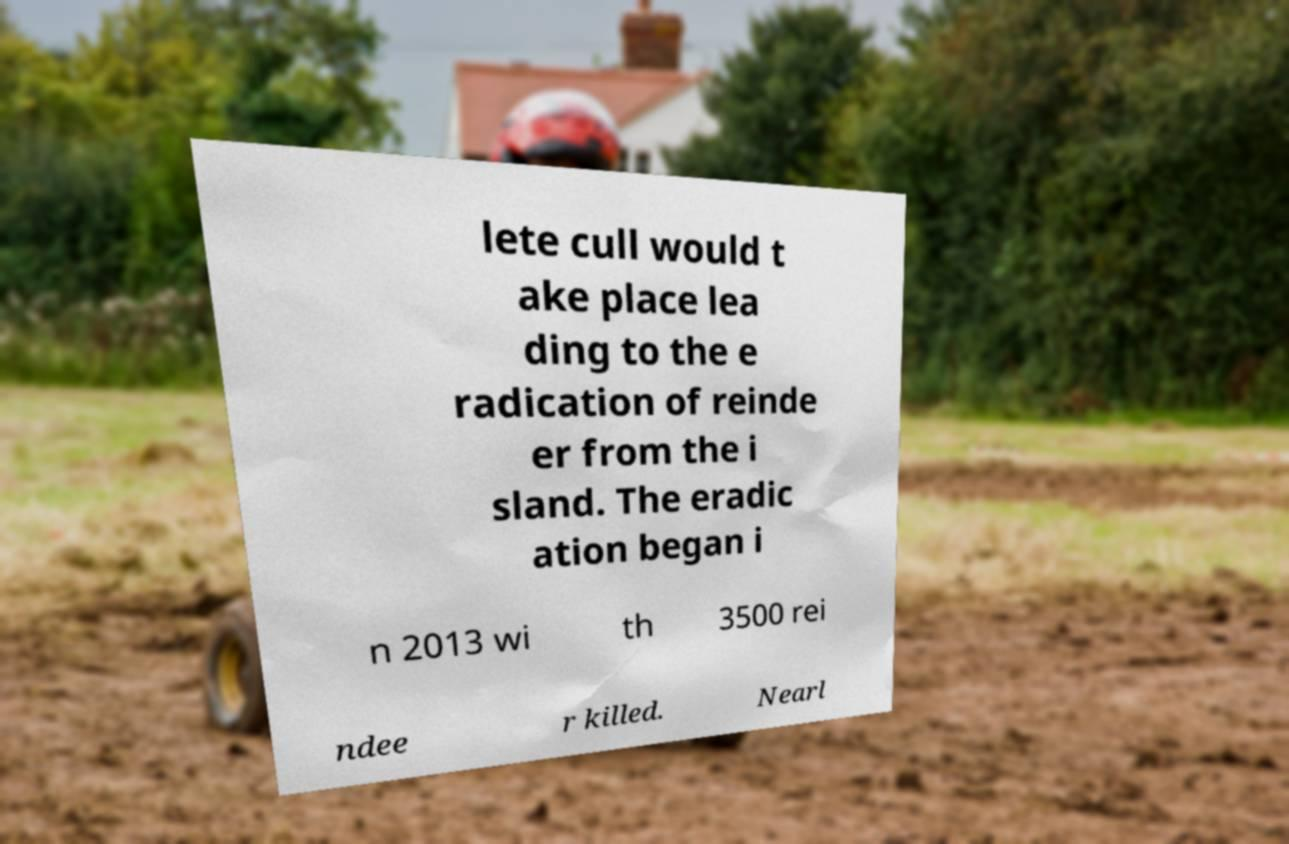I need the written content from this picture converted into text. Can you do that? lete cull would t ake place lea ding to the e radication of reinde er from the i sland. The eradic ation began i n 2013 wi th 3500 rei ndee r killed. Nearl 